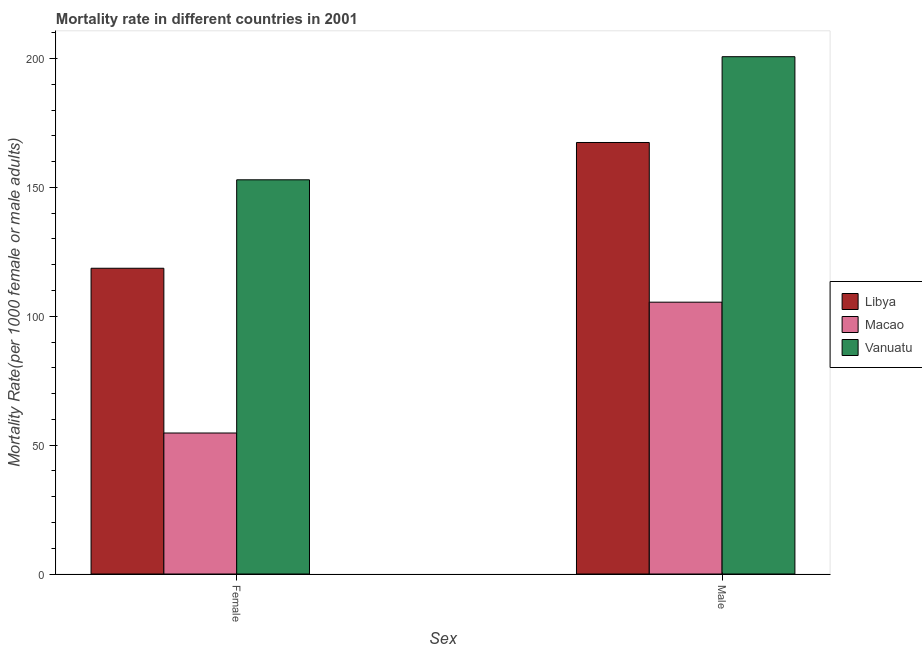How many different coloured bars are there?
Provide a short and direct response. 3. How many groups of bars are there?
Give a very brief answer. 2. Are the number of bars per tick equal to the number of legend labels?
Your answer should be compact. Yes. How many bars are there on the 1st tick from the left?
Offer a terse response. 3. What is the female mortality rate in Vanuatu?
Offer a very short reply. 152.93. Across all countries, what is the maximum female mortality rate?
Provide a short and direct response. 152.93. Across all countries, what is the minimum female mortality rate?
Offer a terse response. 54.7. In which country was the female mortality rate maximum?
Your answer should be compact. Vanuatu. In which country was the male mortality rate minimum?
Provide a succinct answer. Macao. What is the total female mortality rate in the graph?
Your response must be concise. 326.25. What is the difference between the male mortality rate in Vanuatu and that in Libya?
Offer a very short reply. 33.29. What is the difference between the male mortality rate in Vanuatu and the female mortality rate in Libya?
Your answer should be very brief. 82.08. What is the average female mortality rate per country?
Your response must be concise. 108.75. What is the difference between the female mortality rate and male mortality rate in Libya?
Provide a short and direct response. -48.79. What is the ratio of the female mortality rate in Libya to that in Macao?
Ensure brevity in your answer.  2.17. What does the 1st bar from the left in Male represents?
Offer a very short reply. Libya. What does the 2nd bar from the right in Female represents?
Your response must be concise. Macao. Are the values on the major ticks of Y-axis written in scientific E-notation?
Your answer should be very brief. No. Where does the legend appear in the graph?
Provide a succinct answer. Center right. What is the title of the graph?
Your answer should be compact. Mortality rate in different countries in 2001. What is the label or title of the X-axis?
Give a very brief answer. Sex. What is the label or title of the Y-axis?
Ensure brevity in your answer.  Mortality Rate(per 1000 female or male adults). What is the Mortality Rate(per 1000 female or male adults) of Libya in Female?
Make the answer very short. 118.61. What is the Mortality Rate(per 1000 female or male adults) in Macao in Female?
Provide a succinct answer. 54.7. What is the Mortality Rate(per 1000 female or male adults) in Vanuatu in Female?
Provide a short and direct response. 152.93. What is the Mortality Rate(per 1000 female or male adults) in Libya in Male?
Make the answer very short. 167.41. What is the Mortality Rate(per 1000 female or male adults) of Macao in Male?
Give a very brief answer. 105.46. What is the Mortality Rate(per 1000 female or male adults) in Vanuatu in Male?
Your answer should be compact. 200.69. Across all Sex, what is the maximum Mortality Rate(per 1000 female or male adults) of Libya?
Provide a short and direct response. 167.41. Across all Sex, what is the maximum Mortality Rate(per 1000 female or male adults) of Macao?
Provide a succinct answer. 105.46. Across all Sex, what is the maximum Mortality Rate(per 1000 female or male adults) of Vanuatu?
Your answer should be very brief. 200.69. Across all Sex, what is the minimum Mortality Rate(per 1000 female or male adults) in Libya?
Provide a succinct answer. 118.61. Across all Sex, what is the minimum Mortality Rate(per 1000 female or male adults) of Macao?
Your answer should be very brief. 54.7. Across all Sex, what is the minimum Mortality Rate(per 1000 female or male adults) of Vanuatu?
Provide a succinct answer. 152.93. What is the total Mortality Rate(per 1000 female or male adults) of Libya in the graph?
Keep it short and to the point. 286.02. What is the total Mortality Rate(per 1000 female or male adults) in Macao in the graph?
Provide a succinct answer. 160.16. What is the total Mortality Rate(per 1000 female or male adults) of Vanuatu in the graph?
Your response must be concise. 353.63. What is the difference between the Mortality Rate(per 1000 female or male adults) of Libya in Female and that in Male?
Ensure brevity in your answer.  -48.79. What is the difference between the Mortality Rate(per 1000 female or male adults) of Macao in Female and that in Male?
Make the answer very short. -50.76. What is the difference between the Mortality Rate(per 1000 female or male adults) in Vanuatu in Female and that in Male?
Offer a terse response. -47.76. What is the difference between the Mortality Rate(per 1000 female or male adults) in Libya in Female and the Mortality Rate(per 1000 female or male adults) in Macao in Male?
Your answer should be very brief. 13.16. What is the difference between the Mortality Rate(per 1000 female or male adults) in Libya in Female and the Mortality Rate(per 1000 female or male adults) in Vanuatu in Male?
Your answer should be very brief. -82.08. What is the difference between the Mortality Rate(per 1000 female or male adults) of Macao in Female and the Mortality Rate(per 1000 female or male adults) of Vanuatu in Male?
Provide a short and direct response. -145.99. What is the average Mortality Rate(per 1000 female or male adults) in Libya per Sex?
Keep it short and to the point. 143.01. What is the average Mortality Rate(per 1000 female or male adults) in Macao per Sex?
Your response must be concise. 80.08. What is the average Mortality Rate(per 1000 female or male adults) in Vanuatu per Sex?
Your answer should be very brief. 176.81. What is the difference between the Mortality Rate(per 1000 female or male adults) in Libya and Mortality Rate(per 1000 female or male adults) in Macao in Female?
Keep it short and to the point. 63.91. What is the difference between the Mortality Rate(per 1000 female or male adults) of Libya and Mortality Rate(per 1000 female or male adults) of Vanuatu in Female?
Your response must be concise. -34.32. What is the difference between the Mortality Rate(per 1000 female or male adults) of Macao and Mortality Rate(per 1000 female or male adults) of Vanuatu in Female?
Your answer should be very brief. -98.23. What is the difference between the Mortality Rate(per 1000 female or male adults) in Libya and Mortality Rate(per 1000 female or male adults) in Macao in Male?
Your answer should be compact. 61.95. What is the difference between the Mortality Rate(per 1000 female or male adults) of Libya and Mortality Rate(per 1000 female or male adults) of Vanuatu in Male?
Provide a succinct answer. -33.28. What is the difference between the Mortality Rate(per 1000 female or male adults) in Macao and Mortality Rate(per 1000 female or male adults) in Vanuatu in Male?
Your response must be concise. -95.24. What is the ratio of the Mortality Rate(per 1000 female or male adults) in Libya in Female to that in Male?
Your response must be concise. 0.71. What is the ratio of the Mortality Rate(per 1000 female or male adults) of Macao in Female to that in Male?
Your answer should be very brief. 0.52. What is the ratio of the Mortality Rate(per 1000 female or male adults) of Vanuatu in Female to that in Male?
Give a very brief answer. 0.76. What is the difference between the highest and the second highest Mortality Rate(per 1000 female or male adults) of Libya?
Your response must be concise. 48.79. What is the difference between the highest and the second highest Mortality Rate(per 1000 female or male adults) of Macao?
Give a very brief answer. 50.76. What is the difference between the highest and the second highest Mortality Rate(per 1000 female or male adults) of Vanuatu?
Ensure brevity in your answer.  47.76. What is the difference between the highest and the lowest Mortality Rate(per 1000 female or male adults) of Libya?
Provide a short and direct response. 48.79. What is the difference between the highest and the lowest Mortality Rate(per 1000 female or male adults) in Macao?
Offer a terse response. 50.76. What is the difference between the highest and the lowest Mortality Rate(per 1000 female or male adults) in Vanuatu?
Your response must be concise. 47.76. 